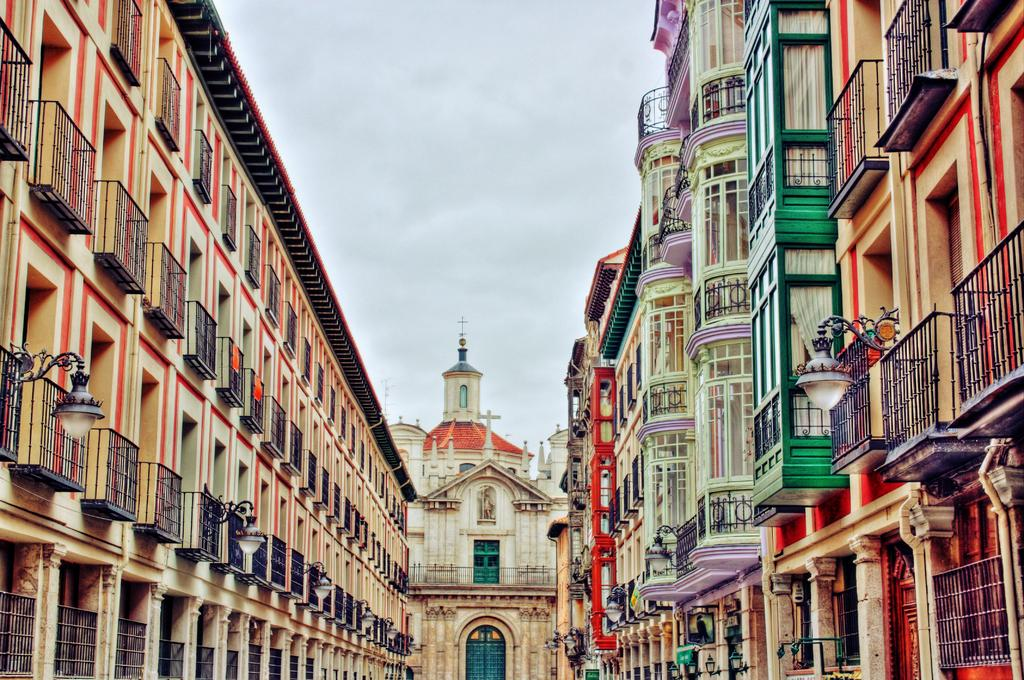What type of structures are located on the right side of the image? There are buildings on the right side of the image. What type of structures are located on the left side of the image? There are buildings on the left side of the image. What type of building is in the center of the image? There is a church in the center of the image. What is visible at the top of the image? The sky is visible at the top of the image. What hope does the church provide for the people in the image? The image does not provide any information about the hope that the church might offer to the people, as it only shows the buildings and the church itself. 